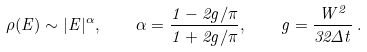<formula> <loc_0><loc_0><loc_500><loc_500>\rho ( E ) \sim | E | ^ { \alpha } , \quad \alpha = \frac { 1 - 2 g / \pi } { 1 + 2 g / \pi } , \quad g = \frac { W ^ { 2 } } { 3 2 \Delta t } \, .</formula> 